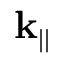<formula> <loc_0><loc_0><loc_500><loc_500>k _ { | | }</formula> 